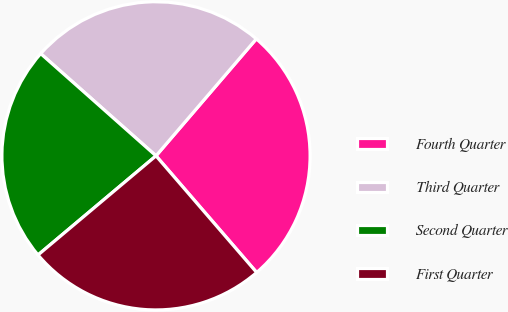Convert chart to OTSL. <chart><loc_0><loc_0><loc_500><loc_500><pie_chart><fcel>Fourth Quarter<fcel>Third Quarter<fcel>Second Quarter<fcel>First Quarter<nl><fcel>27.39%<fcel>24.74%<fcel>22.67%<fcel>25.21%<nl></chart> 